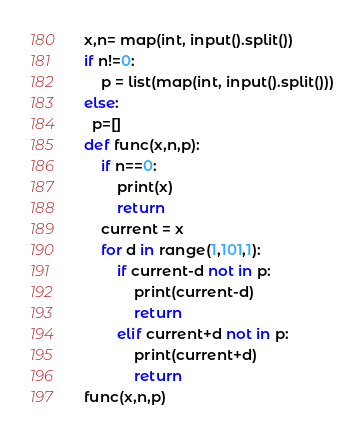Convert code to text. <code><loc_0><loc_0><loc_500><loc_500><_Python_>x,n= map(int, input().split())
if n!=0:
    p = list(map(int, input().split()))
else:
  p=[]
def func(x,n,p):
    if n==0:
        print(x)
        return
    current = x
    for d in range(1,101,1):
        if current-d not in p:
            print(current-d)
            return
        elif current+d not in p:
            print(current+d)
            return
func(x,n,p)</code> 